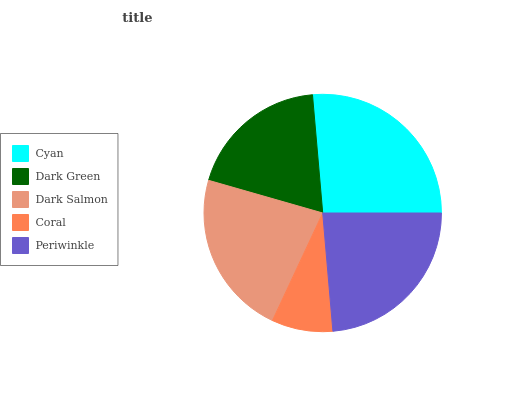Is Coral the minimum?
Answer yes or no. Yes. Is Cyan the maximum?
Answer yes or no. Yes. Is Dark Green the minimum?
Answer yes or no. No. Is Dark Green the maximum?
Answer yes or no. No. Is Cyan greater than Dark Green?
Answer yes or no. Yes. Is Dark Green less than Cyan?
Answer yes or no. Yes. Is Dark Green greater than Cyan?
Answer yes or no. No. Is Cyan less than Dark Green?
Answer yes or no. No. Is Dark Salmon the high median?
Answer yes or no. Yes. Is Dark Salmon the low median?
Answer yes or no. Yes. Is Cyan the high median?
Answer yes or no. No. Is Dark Green the low median?
Answer yes or no. No. 